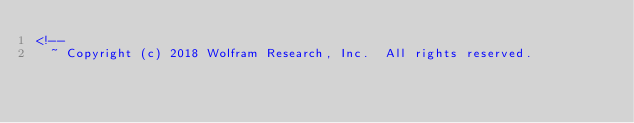Convert code to text. <code><loc_0><loc_0><loc_500><loc_500><_HTML_><!--
  ~ Copyright (c) 2018 Wolfram Research, Inc.  All rights reserved.</code> 